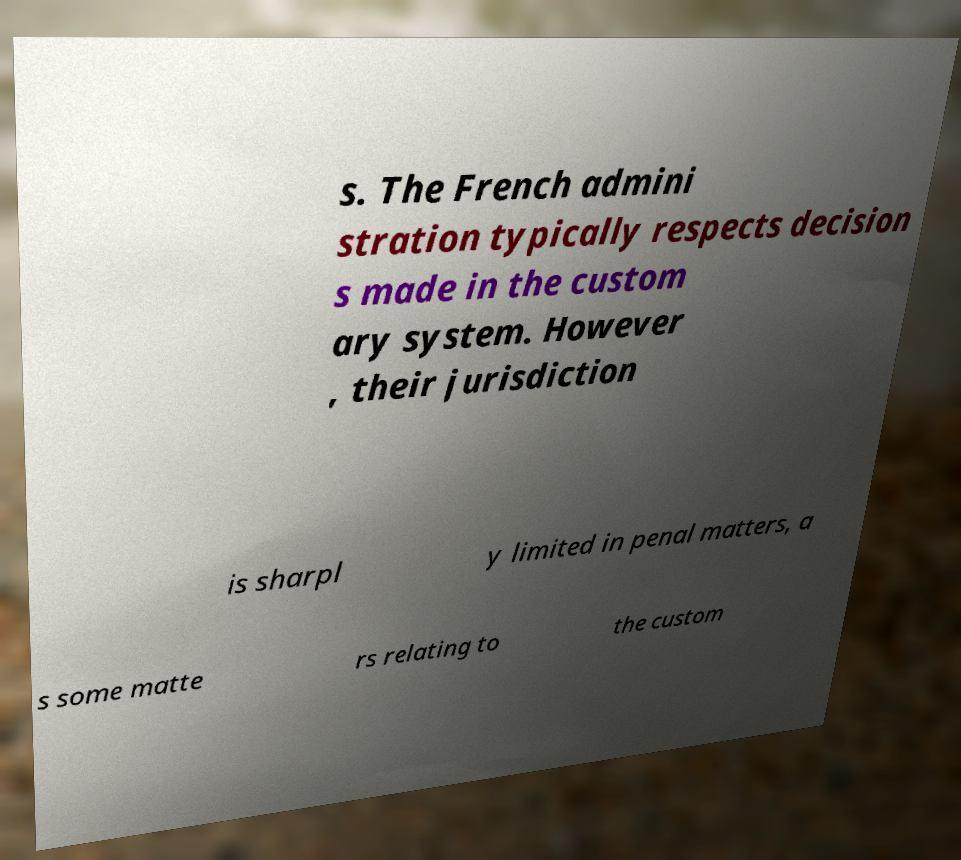There's text embedded in this image that I need extracted. Can you transcribe it verbatim? s. The French admini stration typically respects decision s made in the custom ary system. However , their jurisdiction is sharpl y limited in penal matters, a s some matte rs relating to the custom 